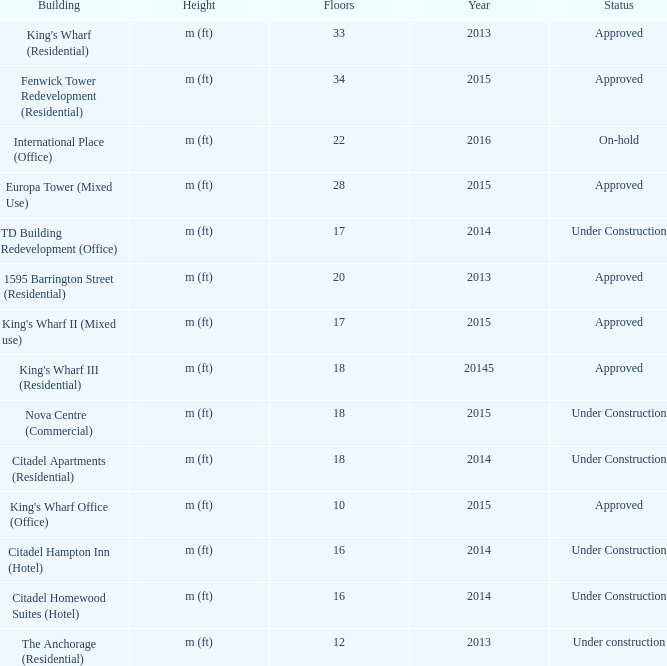What is the status of the building with less than 18 floors and later than 2013? Under Construction, Approved, Approved, Under Construction, Under Construction. 